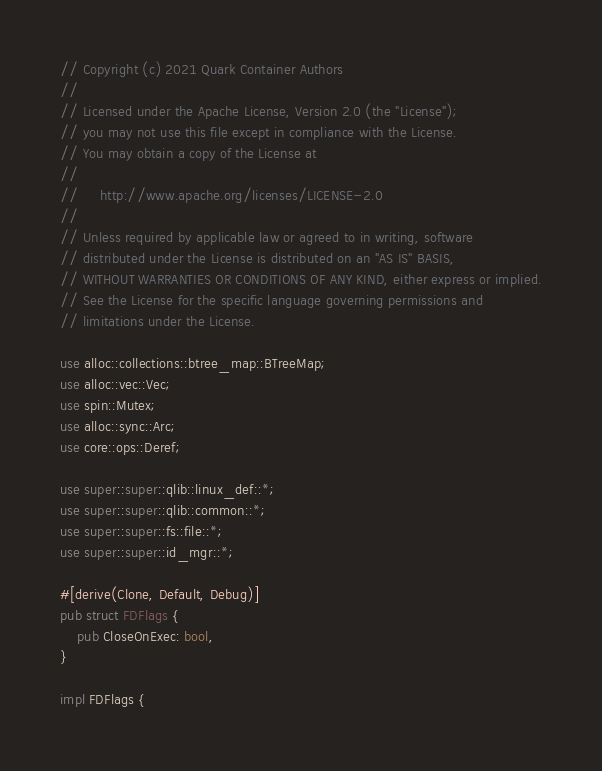Convert code to text. <code><loc_0><loc_0><loc_500><loc_500><_Rust_>// Copyright (c) 2021 Quark Container Authors
//
// Licensed under the Apache License, Version 2.0 (the "License");
// you may not use this file except in compliance with the License.
// You may obtain a copy of the License at
//
//     http://www.apache.org/licenses/LICENSE-2.0
//
// Unless required by applicable law or agreed to in writing, software
// distributed under the License is distributed on an "AS IS" BASIS,
// WITHOUT WARRANTIES OR CONDITIONS OF ANY KIND, either express or implied.
// See the License for the specific language governing permissions and
// limitations under the License.

use alloc::collections::btree_map::BTreeMap;
use alloc::vec::Vec;
use spin::Mutex;
use alloc::sync::Arc;
use core::ops::Deref;

use super::super::qlib::linux_def::*;
use super::super::qlib::common::*;
use super::super::fs::file::*;
use super::super::id_mgr::*;

#[derive(Clone, Default, Debug)]
pub struct FDFlags {
    pub CloseOnExec: bool,
}

impl FDFlags {</code> 